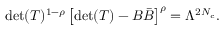<formula> <loc_0><loc_0><loc_500><loc_500>d e t ( T ) ^ { 1 - \rho } \left [ d e t ( T ) - B { \bar { B } } \right ] ^ { \rho } = \Lambda ^ { 2 N _ { c } } .</formula> 